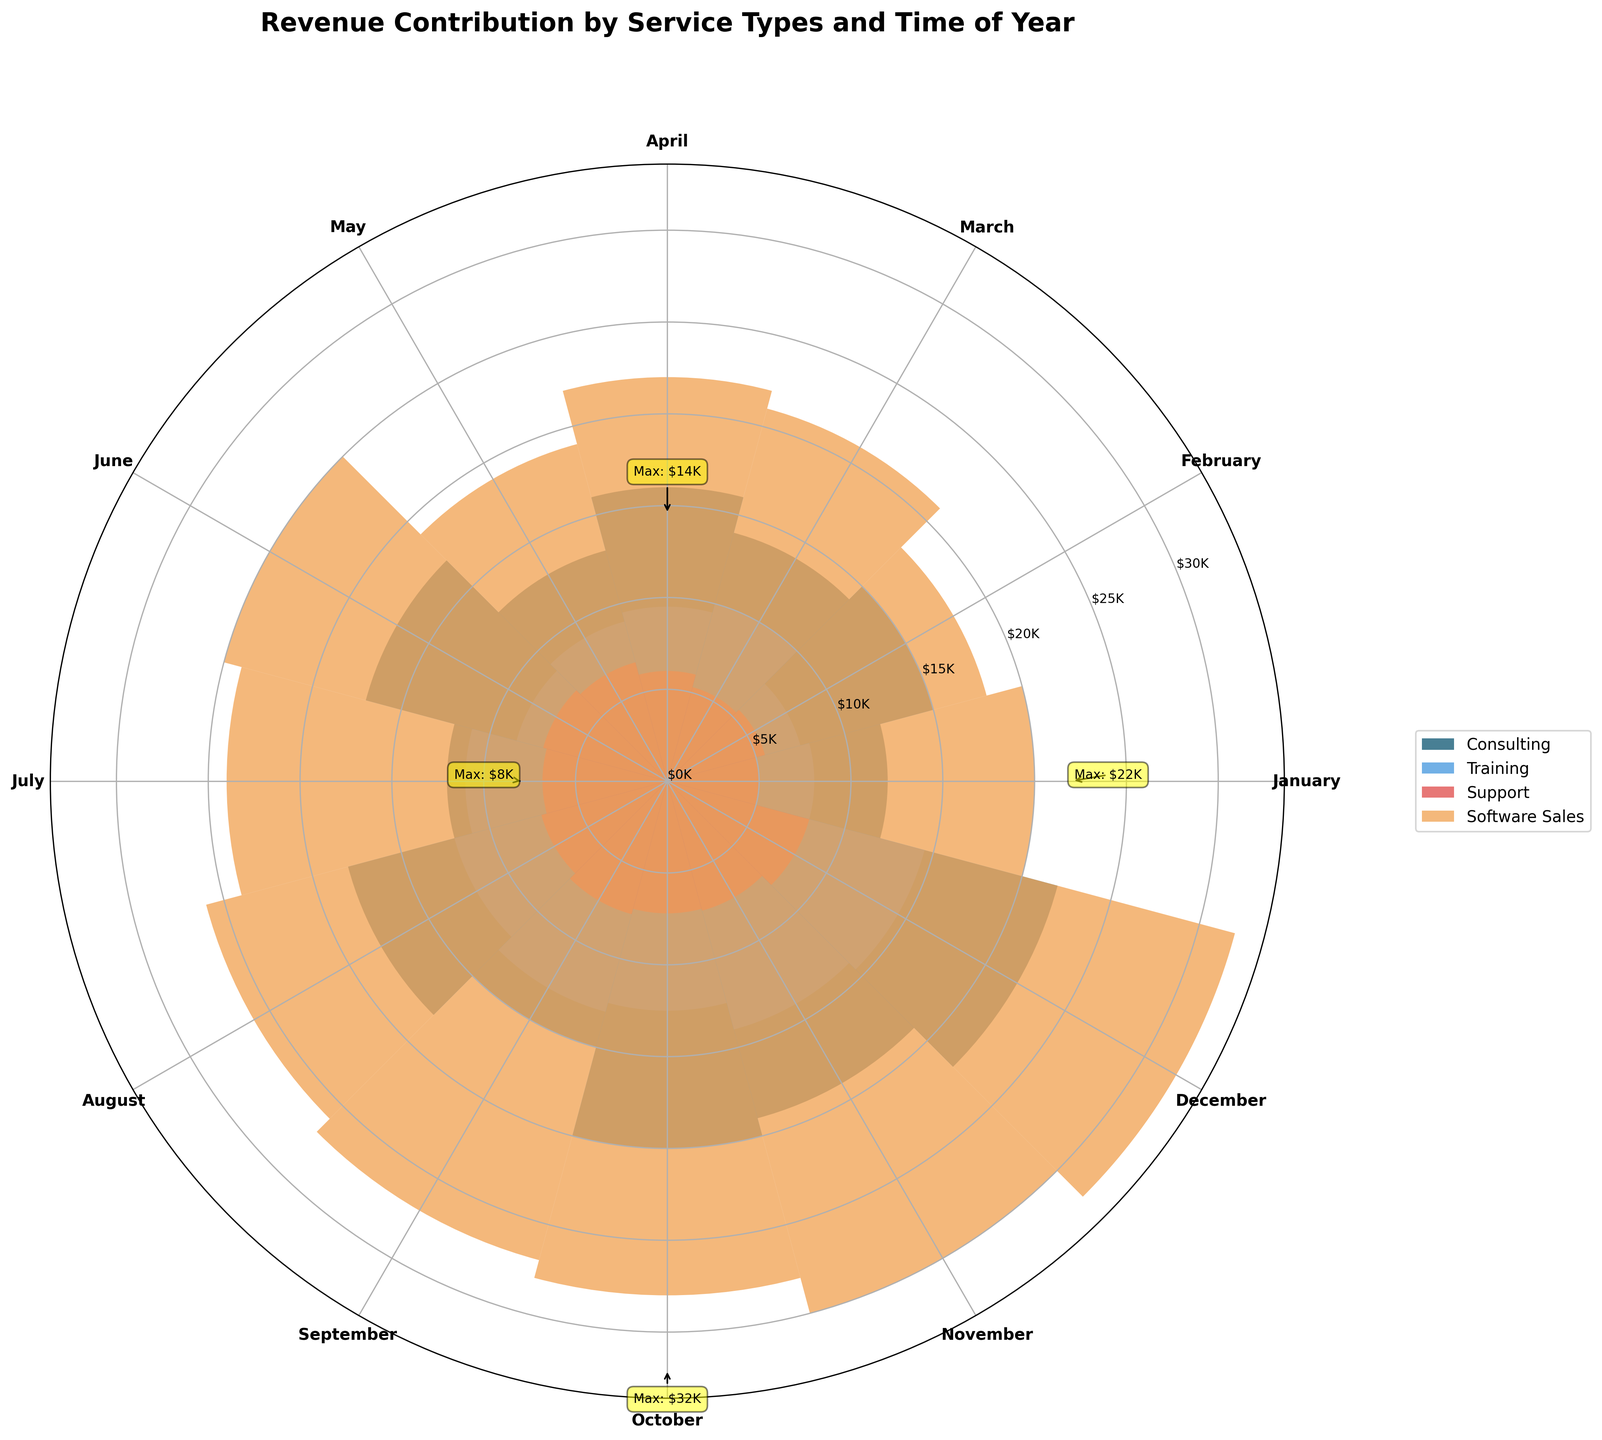what are the service types shown in the plot? The plot contains revenue data for different service types which are labeled individually in the legend. Observe the legend to identify each type.
Answer: Consulting, Training, Support, Software Sales which month contributes the highest revenue in Support services? Locate the Support services section in the plot. Track the radii (revenue bars) for each month and find the longest bar corresponding to the highest value.
Answer: December what is the maximum revenue for Consulting services? Look at the annotations or the highest bar in the Consulting section. The plot specifies the maximum value as an annotated figure above the tallest bar.
Answer: $22K during which month does Software Sales reach its maximum revenue? Identify Software Sales in the legend and follow the respective bars for each month. The longest bar represents the month with maximum revenue.
Answer: December compare the revenues of Training and Support services in July. Check the July section for both Training and Support bars. Comparing their lengths will show which service has higher revenue.
Answer: Training: $11K, Support: $6.8K what is the average revenue for Consulting services for the first quarter (January to March)? Identify the revenue bars for Consulting services in January, February, and March. Add these values and divide by the number of months. Calculation: (12000 + 15000 + 14000) / 3 = 41000 / 3.
Answer: $13.67K which service type has the highest revenue in October, and what is its value? Find October in the plot and compare revenue bars for all service types. The highest bar represents the service with the highest revenue.
Answer: Software Sales: $28K does Training or Support have a more consistent revenue pattern throughout the year? Compare the variability in the heights of the bars throughout the months for Training and Support. A more consistent pattern shows less variation in bar heights.
Answer: Training how does the total annual revenue for Software Sales compare to Consulting? Add up monthly revenues for Software Sales and Consulting over the year and compare the totals. Using values: Software Sales = 287000, Consulting = 198000.
Answer: Software Sales is higher how does the revenue trend for Consulting services change from July to December? Follow Consulting bars from July to December and observe the increasing or decreasing pattern in the length of the bars to determine the trend.
Answer: Increasing 